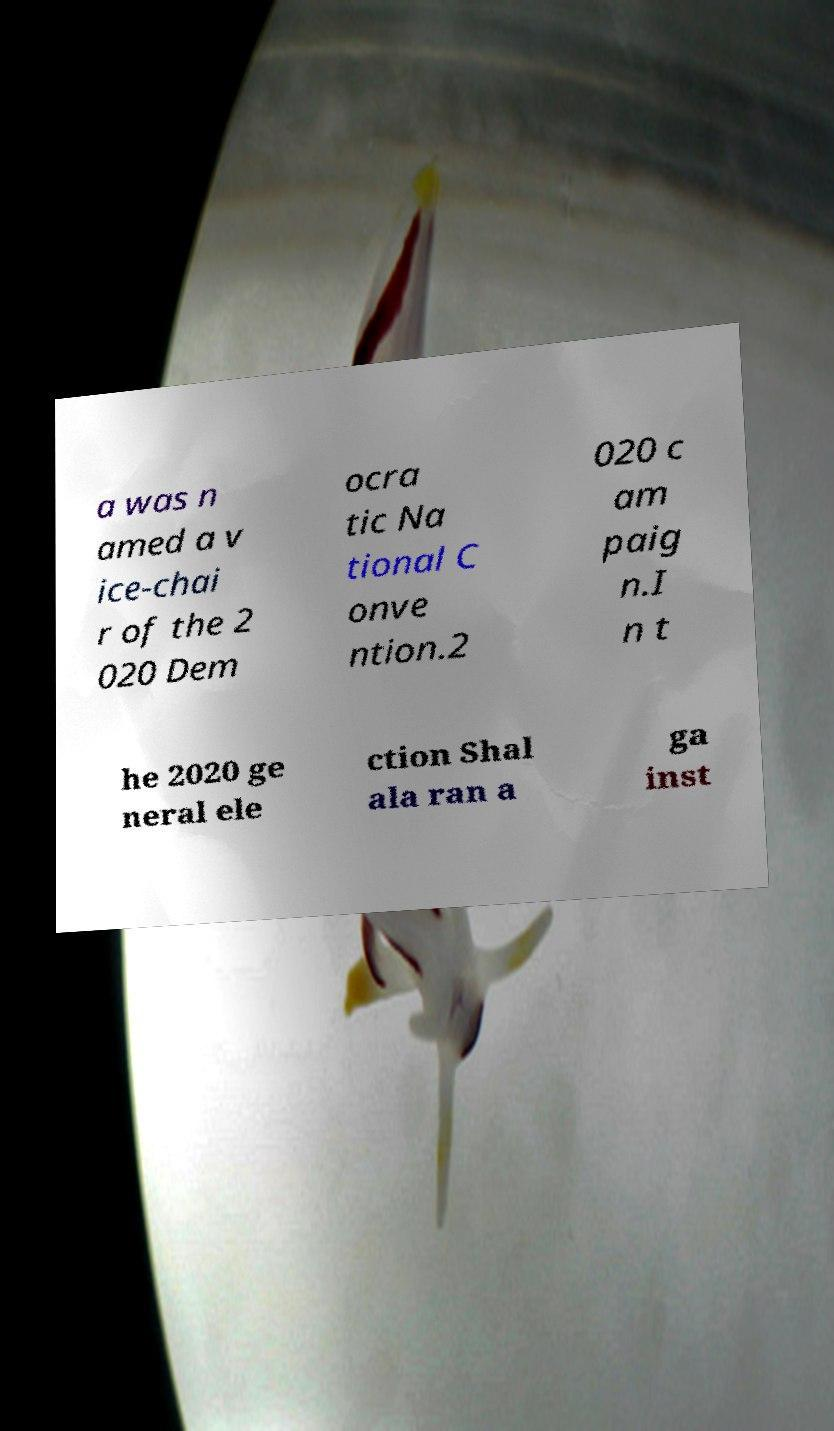For documentation purposes, I need the text within this image transcribed. Could you provide that? a was n amed a v ice-chai r of the 2 020 Dem ocra tic Na tional C onve ntion.2 020 c am paig n.I n t he 2020 ge neral ele ction Shal ala ran a ga inst 